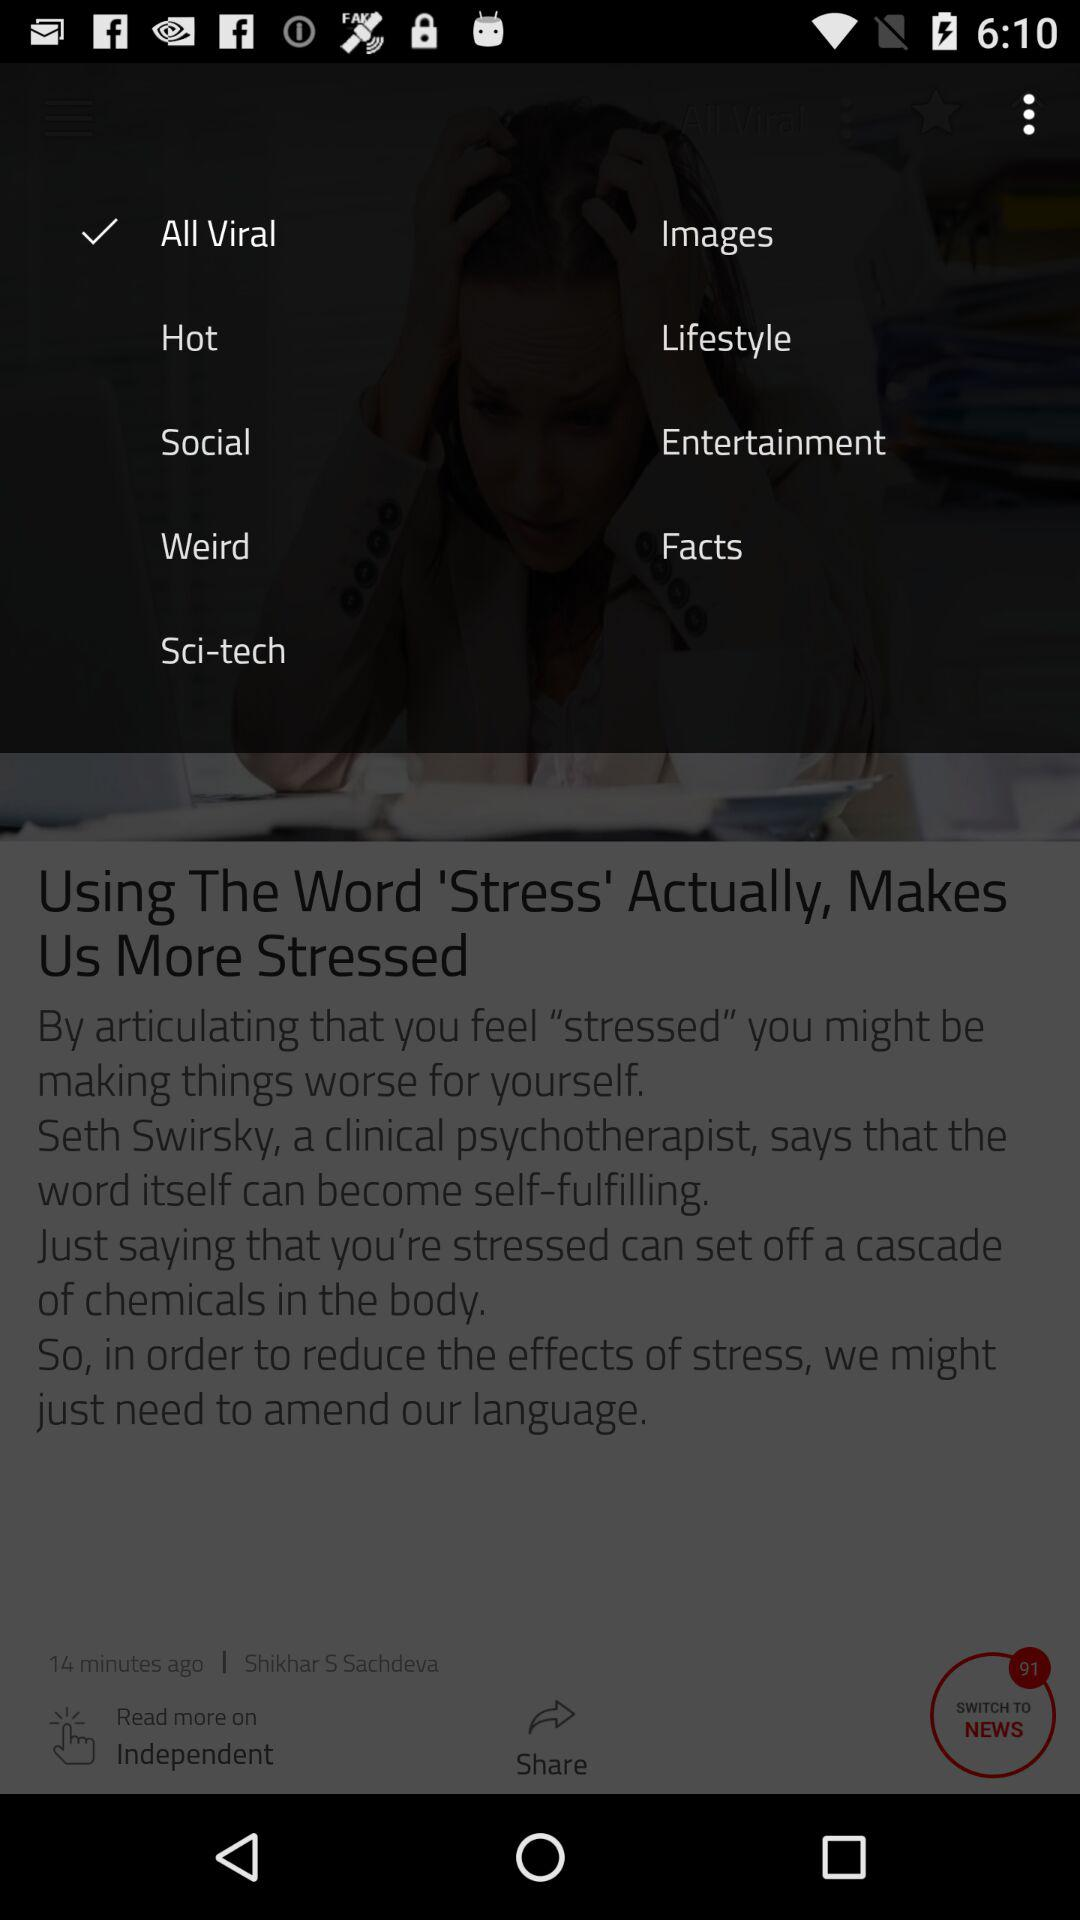Which option is selected? The selected option is "All Viral". 